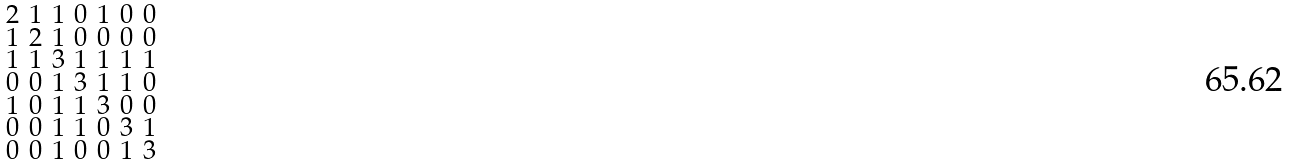<formula> <loc_0><loc_0><loc_500><loc_500>\begin{smallmatrix} 2 & 1 & 1 & 0 & 1 & 0 & 0 \\ 1 & 2 & 1 & 0 & 0 & 0 & 0 \\ 1 & 1 & 3 & 1 & 1 & 1 & 1 \\ 0 & 0 & 1 & 3 & 1 & 1 & 0 \\ 1 & 0 & 1 & 1 & 3 & 0 & 0 \\ 0 & 0 & 1 & 1 & 0 & 3 & 1 \\ 0 & 0 & 1 & 0 & 0 & 1 & 3 \end{smallmatrix}</formula> 